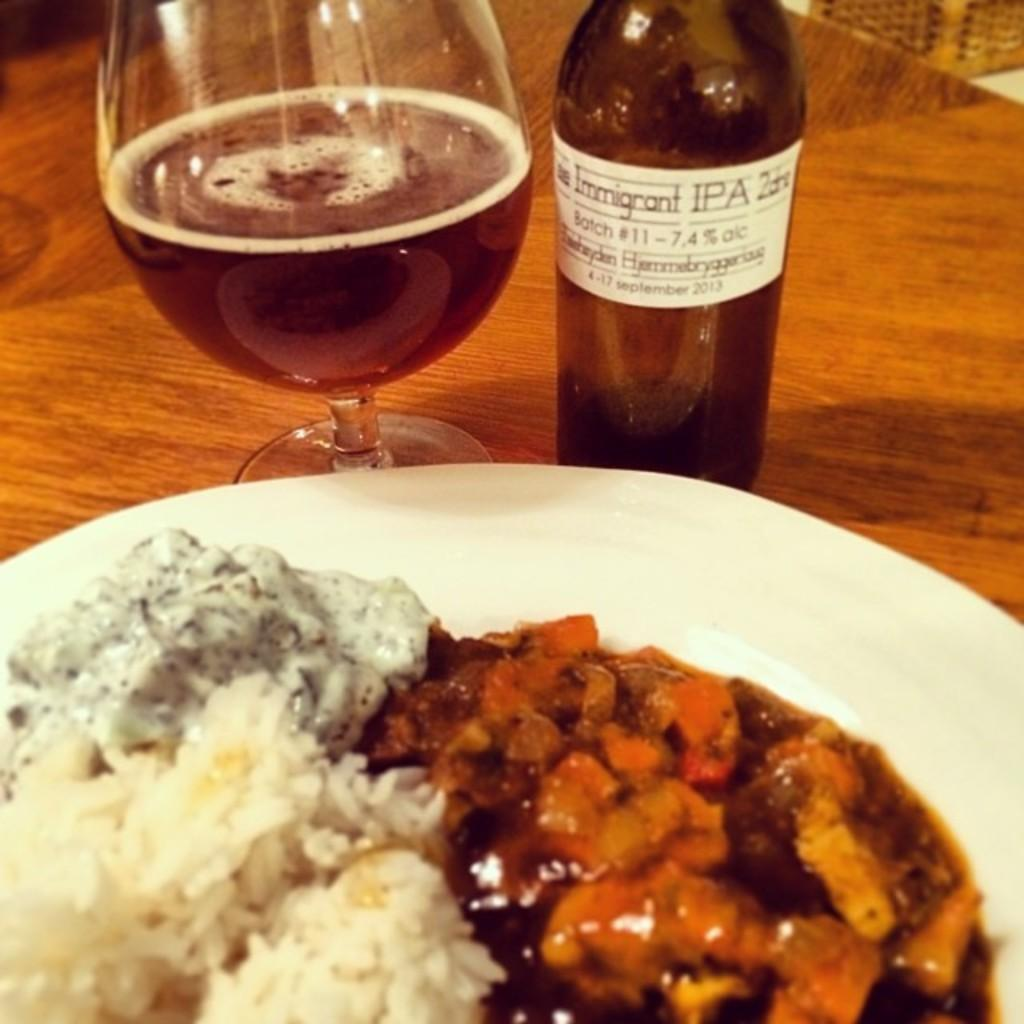What piece of furniture is present in the image? There is a table in the image. What is placed on the table? There is a plate and a bottle on the table. What is on the plate? There is food on the plate. What else is on the table for drinking? There is a glass on the table. Can you see the grandfather flying an airplane in the image? There is no grandfather or airplane present in the image. What action is the food performing in the image? The food is not performing any action; it is simply sitting on the plate. 